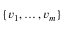<formula> <loc_0><loc_0><loc_500><loc_500>\{ v _ { 1 } , \dots c , v _ { m } \}</formula> 